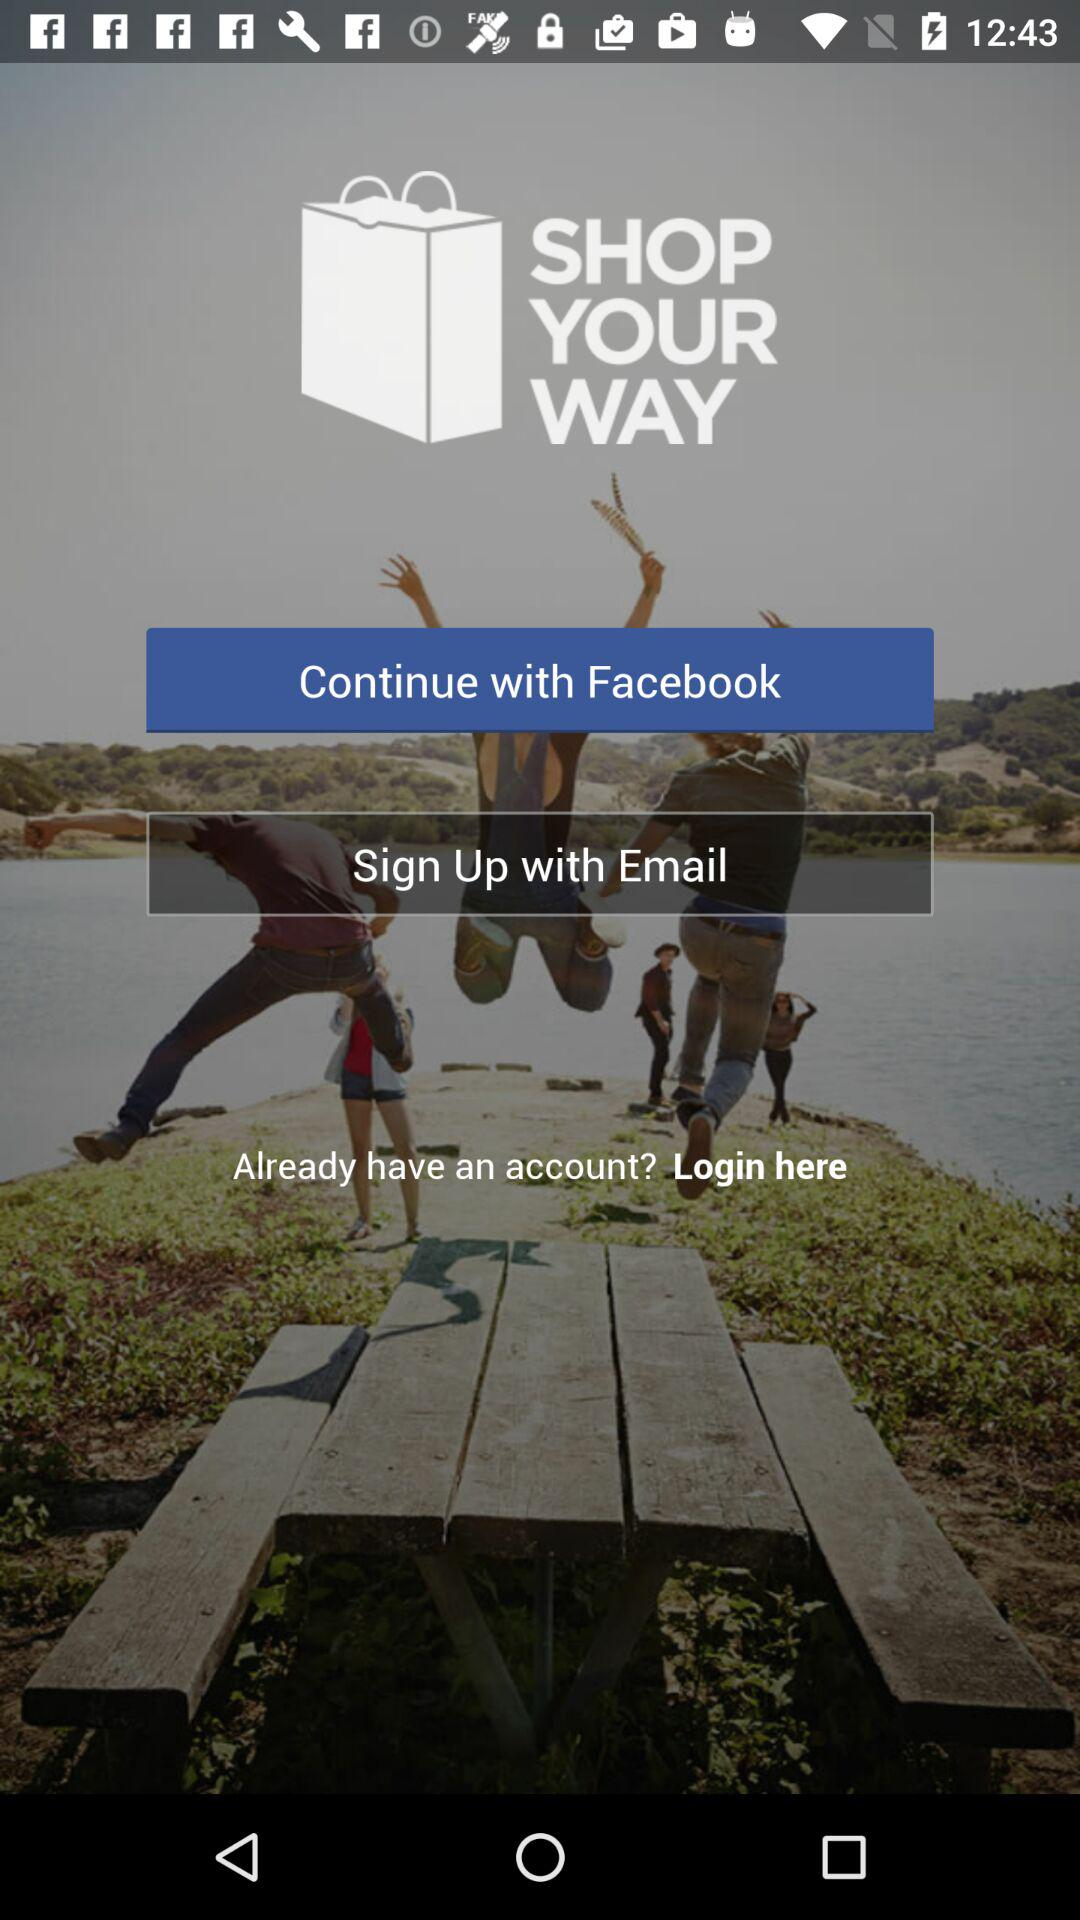What can be shopped for?
When the provided information is insufficient, respond with <no answer>. <no answer> 